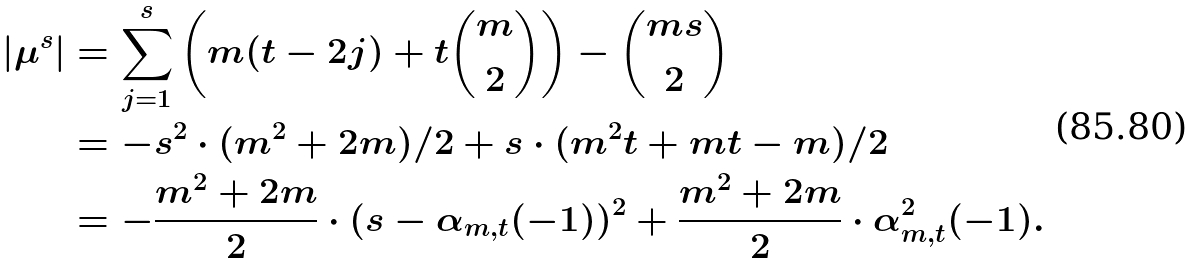<formula> <loc_0><loc_0><loc_500><loc_500>| \mu ^ { s } | & = \sum _ { j = 1 } ^ { s } \left ( m ( t - 2 j ) + t \binom { m } { 2 } \right ) - \binom { m s } { 2 } \\ & = - s ^ { 2 } \cdot ( m ^ { 2 } + 2 m ) / { 2 } + s \cdot ( m ^ { 2 } t + m t - m ) / { 2 } \\ & = - \frac { m ^ { 2 } + 2 m } { 2 } \cdot ( s - \alpha _ { m , t } ( - 1 ) ) ^ { 2 } + \frac { m ^ { 2 } + 2 m } { 2 } \cdot \alpha ^ { 2 } _ { m , t } ( - 1 ) .</formula> 